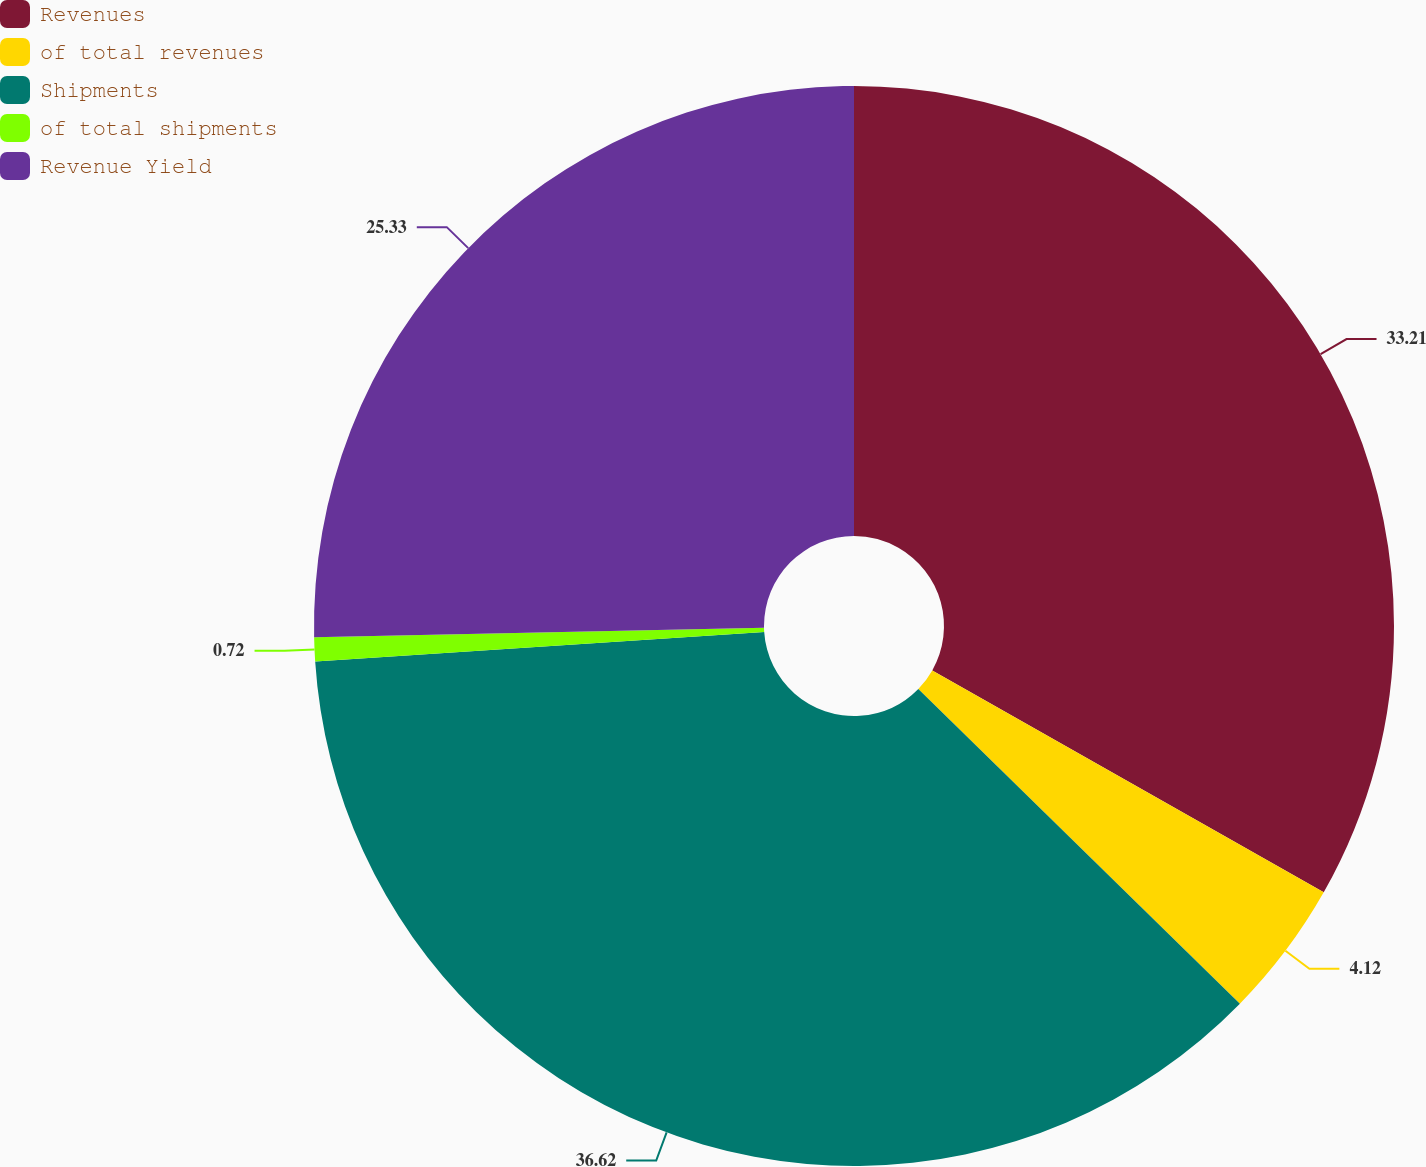Convert chart. <chart><loc_0><loc_0><loc_500><loc_500><pie_chart><fcel>Revenues<fcel>of total revenues<fcel>Shipments<fcel>of total shipments<fcel>Revenue Yield<nl><fcel>33.21%<fcel>4.12%<fcel>36.62%<fcel>0.72%<fcel>25.33%<nl></chart> 